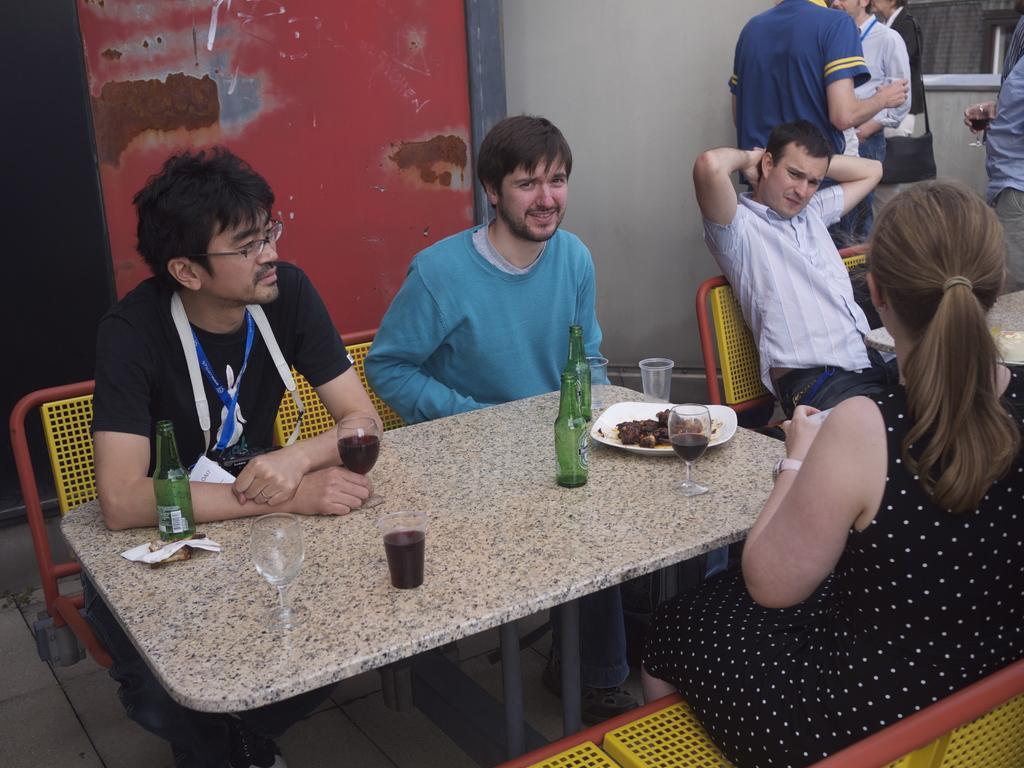Please provide a concise description of this image. In this Image I see 3 men and a woman who are sitting on chairs and there are tables in front of them on which, there are bottles, glasses and plate full of food. I can also see this man is smiling. In the background I see the wall and few people over here and I see that they're holding glasses. 